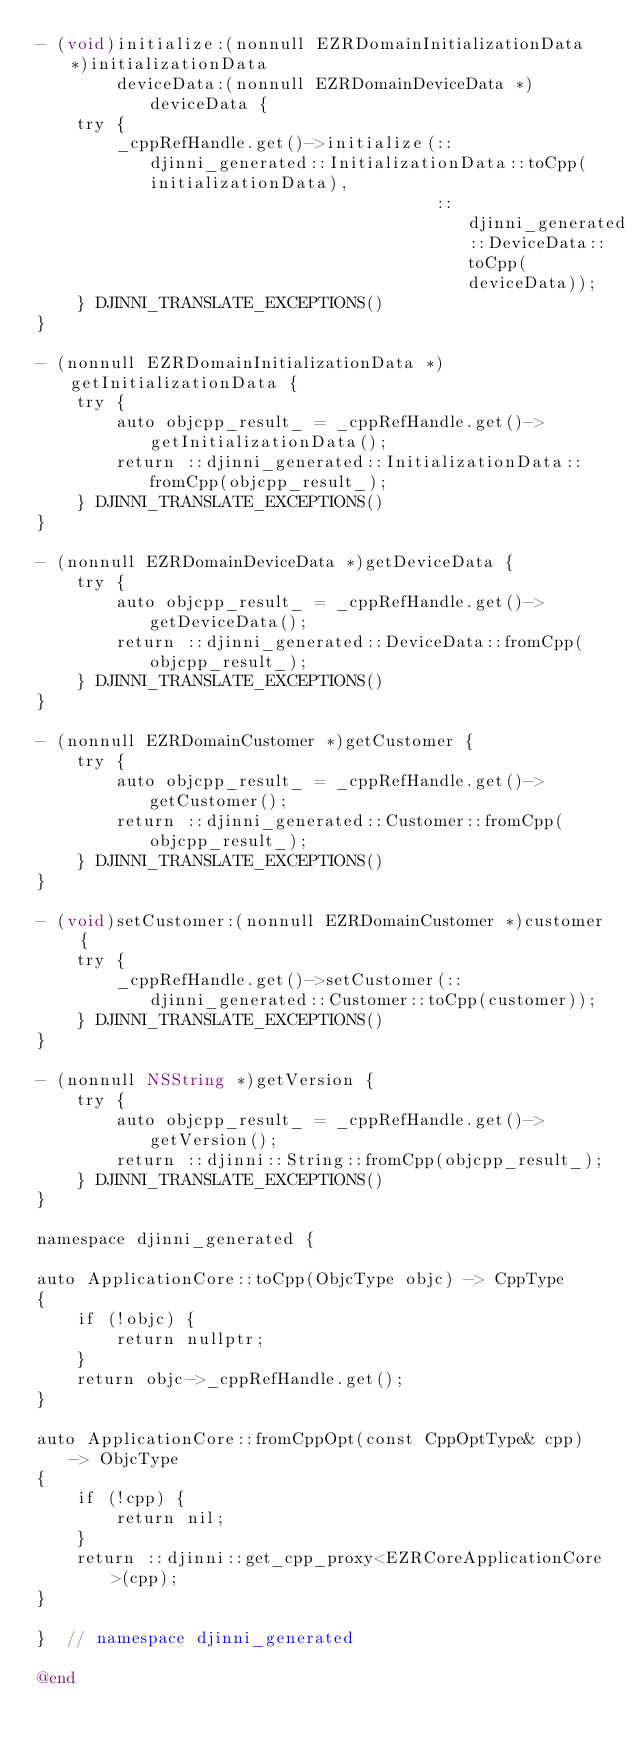<code> <loc_0><loc_0><loc_500><loc_500><_ObjectiveC_>- (void)initialize:(nonnull EZRDomainInitializationData *)initializationData
        deviceData:(nonnull EZRDomainDeviceData *)deviceData {
    try {
        _cppRefHandle.get()->initialize(::djinni_generated::InitializationData::toCpp(initializationData),
                                        ::djinni_generated::DeviceData::toCpp(deviceData));
    } DJINNI_TRANSLATE_EXCEPTIONS()
}

- (nonnull EZRDomainInitializationData *)getInitializationData {
    try {
        auto objcpp_result_ = _cppRefHandle.get()->getInitializationData();
        return ::djinni_generated::InitializationData::fromCpp(objcpp_result_);
    } DJINNI_TRANSLATE_EXCEPTIONS()
}

- (nonnull EZRDomainDeviceData *)getDeviceData {
    try {
        auto objcpp_result_ = _cppRefHandle.get()->getDeviceData();
        return ::djinni_generated::DeviceData::fromCpp(objcpp_result_);
    } DJINNI_TRANSLATE_EXCEPTIONS()
}

- (nonnull EZRDomainCustomer *)getCustomer {
    try {
        auto objcpp_result_ = _cppRefHandle.get()->getCustomer();
        return ::djinni_generated::Customer::fromCpp(objcpp_result_);
    } DJINNI_TRANSLATE_EXCEPTIONS()
}

- (void)setCustomer:(nonnull EZRDomainCustomer *)customer {
    try {
        _cppRefHandle.get()->setCustomer(::djinni_generated::Customer::toCpp(customer));
    } DJINNI_TRANSLATE_EXCEPTIONS()
}

- (nonnull NSString *)getVersion {
    try {
        auto objcpp_result_ = _cppRefHandle.get()->getVersion();
        return ::djinni::String::fromCpp(objcpp_result_);
    } DJINNI_TRANSLATE_EXCEPTIONS()
}

namespace djinni_generated {

auto ApplicationCore::toCpp(ObjcType objc) -> CppType
{
    if (!objc) {
        return nullptr;
    }
    return objc->_cppRefHandle.get();
}

auto ApplicationCore::fromCppOpt(const CppOptType& cpp) -> ObjcType
{
    if (!cpp) {
        return nil;
    }
    return ::djinni::get_cpp_proxy<EZRCoreApplicationCore>(cpp);
}

}  // namespace djinni_generated

@end
</code> 